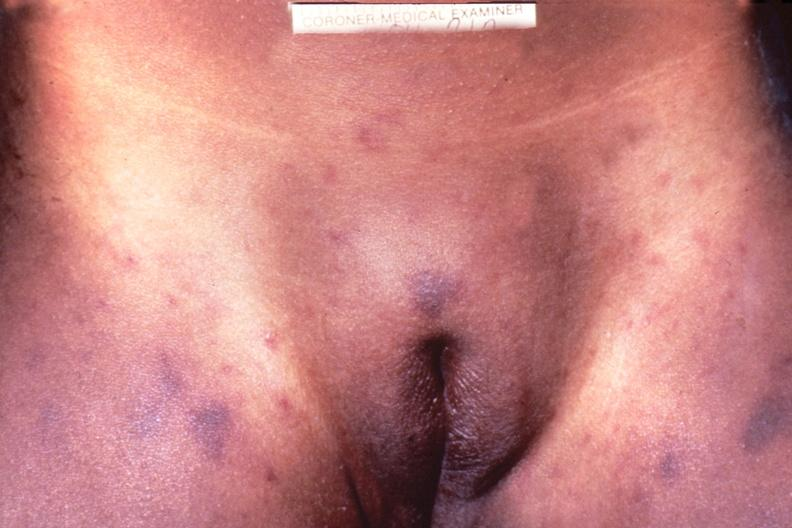does excellent vertebral body primary show meningococcemia, petechia?
Answer the question using a single word or phrase. No 